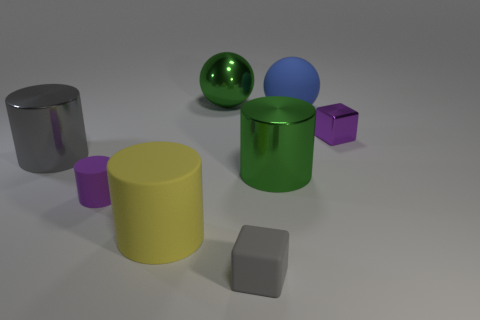Subtract 1 cylinders. How many cylinders are left? 3 Add 1 purple rubber things. How many objects exist? 9 Subtract all blocks. How many objects are left? 6 Add 5 gray blocks. How many gray blocks are left? 6 Add 7 big blue metallic cubes. How many big blue metallic cubes exist? 7 Subtract 1 gray blocks. How many objects are left? 7 Subtract all gray metal cylinders. Subtract all big blue matte things. How many objects are left? 6 